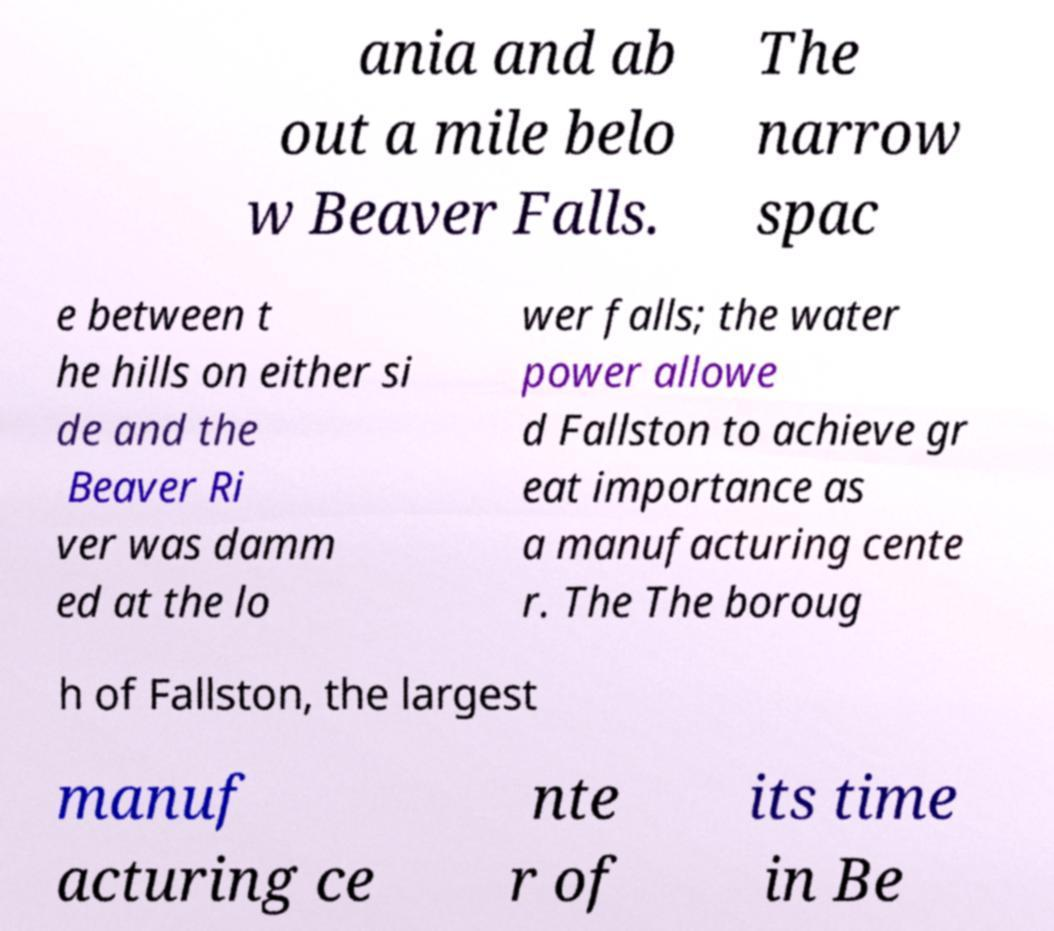Could you extract and type out the text from this image? ania and ab out a mile belo w Beaver Falls. The narrow spac e between t he hills on either si de and the Beaver Ri ver was damm ed at the lo wer falls; the water power allowe d Fallston to achieve gr eat importance as a manufacturing cente r. The The boroug h of Fallston, the largest manuf acturing ce nte r of its time in Be 